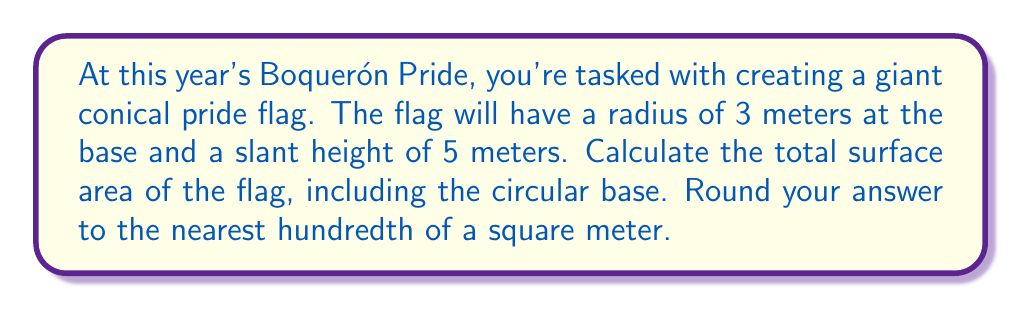Show me your answer to this math problem. Let's approach this step-by-step:

1) The surface area of a cone consists of two parts:
   a) The lateral surface area (the curved part)
   b) The area of the circular base

2) For the lateral surface area, we use the formula:
   $$ A_{\text{lateral}} = \pi r s $$
   where $r$ is the radius of the base and $s$ is the slant height.

3) Given: $r = 3$ m and $s = 5$ m
   $$ A_{\text{lateral}} = \pi (3)(5) = 15\pi \text{ m}^2 $$

4) For the circular base, we use the formula:
   $$ A_{\text{base}} = \pi r^2 $$

5) Substituting $r = 3$ m:
   $$ A_{\text{base}} = \pi (3)^2 = 9\pi \text{ m}^2 $$

6) The total surface area is the sum of these two:
   $$ A_{\text{total}} = A_{\text{lateral}} + A_{\text{base}} = 15\pi + 9\pi = 24\pi \text{ m}^2 $$

7) Calculate and round to the nearest hundredth:
   $$ 24\pi \approx 75.40 \text{ m}^2 $$

[asy]
import geometry;

size(200);
pair O=(0,0);
pair A=(3,0);
pair B=(0,4);
draw(O--A--B--O);
draw(arc(O,3,0,90));
label("3 m",A/2,S);
label("5 m",(A+B)/2,NE);
[/asy]
Answer: 75.40 m² 